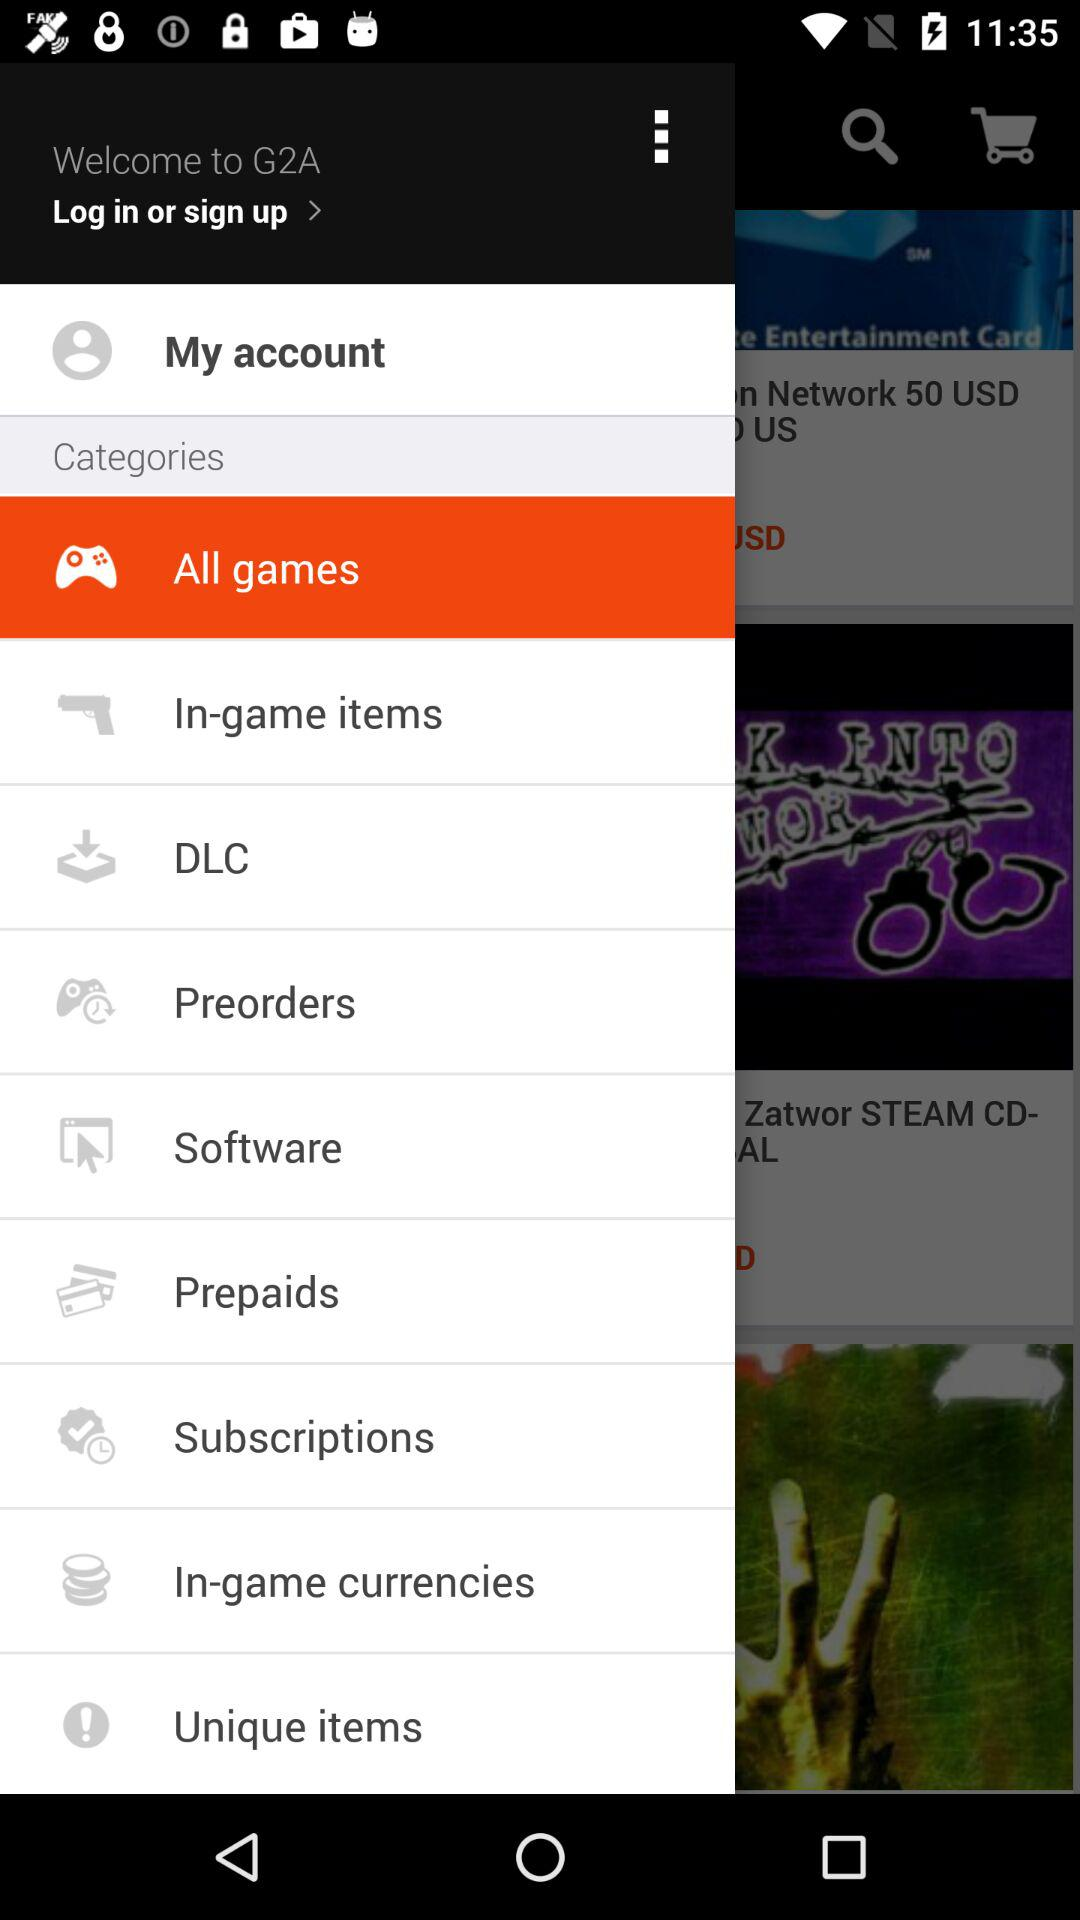What is the application name? The application name is "G2A". 